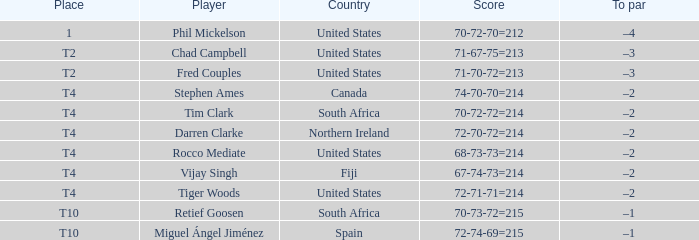What place was the scorer of 67-74-73=214? T4. Parse the table in full. {'header': ['Place', 'Player', 'Country', 'Score', 'To par'], 'rows': [['1', 'Phil Mickelson', 'United States', '70-72-70=212', '–4'], ['T2', 'Chad Campbell', 'United States', '71-67-75=213', '–3'], ['T2', 'Fred Couples', 'United States', '71-70-72=213', '–3'], ['T4', 'Stephen Ames', 'Canada', '74-70-70=214', '–2'], ['T4', 'Tim Clark', 'South Africa', '70-72-72=214', '–2'], ['T4', 'Darren Clarke', 'Northern Ireland', '72-70-72=214', '–2'], ['T4', 'Rocco Mediate', 'United States', '68-73-73=214', '–2'], ['T4', 'Vijay Singh', 'Fiji', '67-74-73=214', '–2'], ['T4', 'Tiger Woods', 'United States', '72-71-71=214', '–2'], ['T10', 'Retief Goosen', 'South Africa', '70-73-72=215', '–1'], ['T10', 'Miguel Ángel Jiménez', 'Spain', '72-74-69=215', '–1']]} 